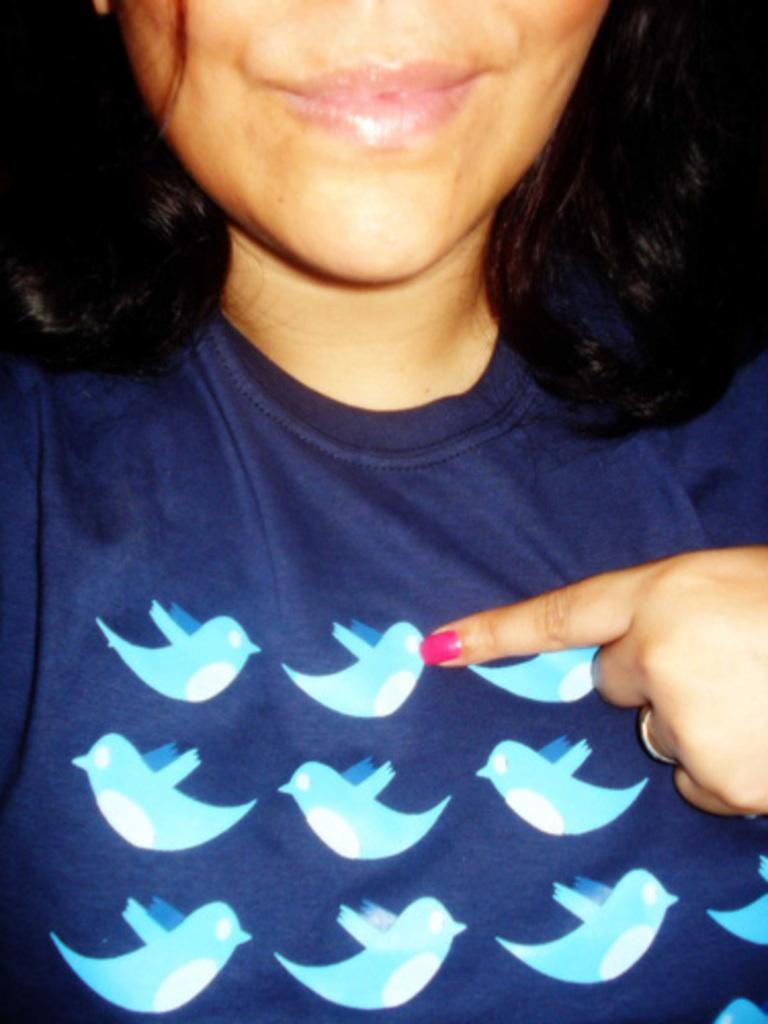Who is present in the image? There is a woman in the image. What is the woman wearing? The woman is wearing a navy blue t-shirt. Can you describe the design on the t-shirt? The t-shirt has bird images on it. What type of servant is depicted in the image? There is no servant depicted in the image; it features a woman wearing a navy blue t-shirt with bird images on it. 